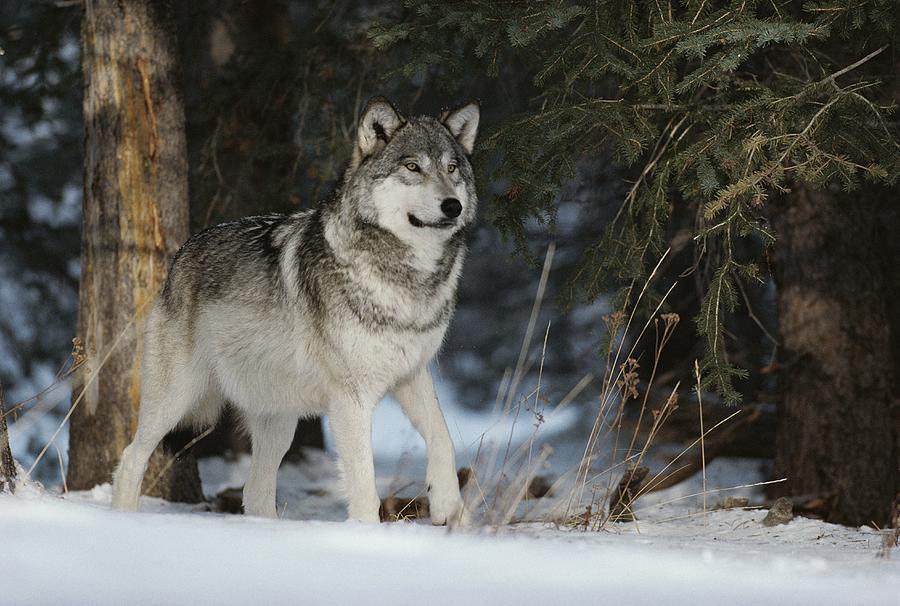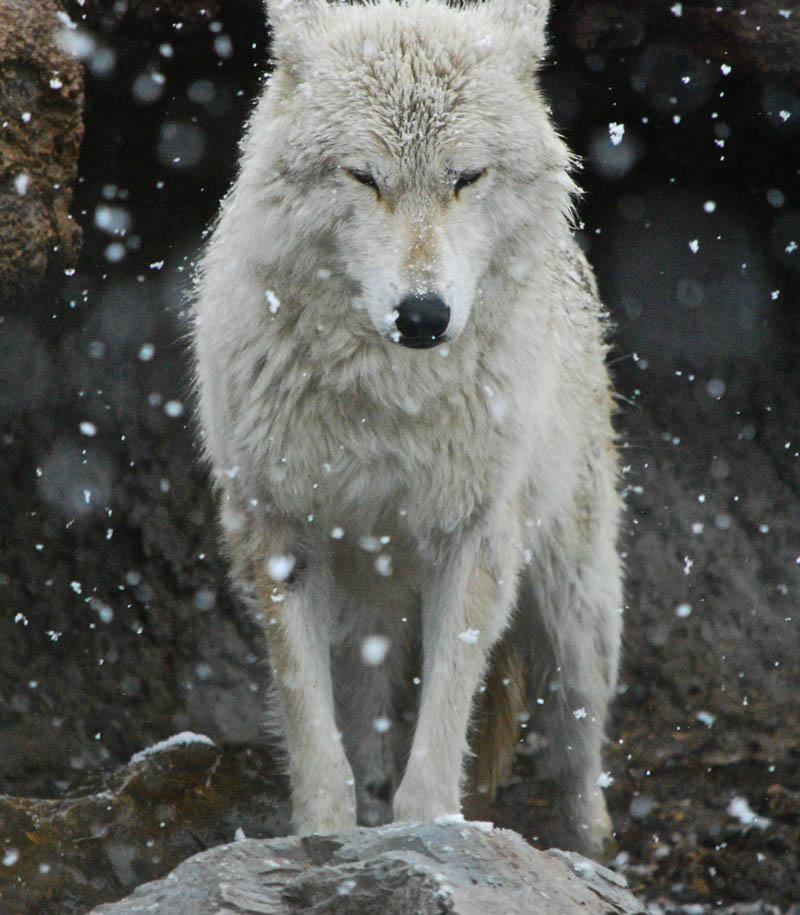The first image is the image on the left, the second image is the image on the right. Examine the images to the left and right. Is the description "One image shows two wolves with one wolf on the ground and one standing, and the other image shows one wolf with all teeth bared and visible." accurate? Answer yes or no. No. The first image is the image on the left, the second image is the image on the right. Evaluate the accuracy of this statement regarding the images: "There is no more than one wolf in the right image.". Is it true? Answer yes or no. Yes. 